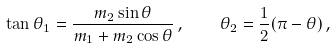<formula> <loc_0><loc_0><loc_500><loc_500>\tan \theta _ { 1 } = \frac { m _ { 2 } \sin \theta } { m _ { 1 } + m _ { 2 } \cos \theta } \, , \quad \theta _ { 2 } = \frac { 1 } { 2 } ( \pi - \theta ) \, ,</formula> 